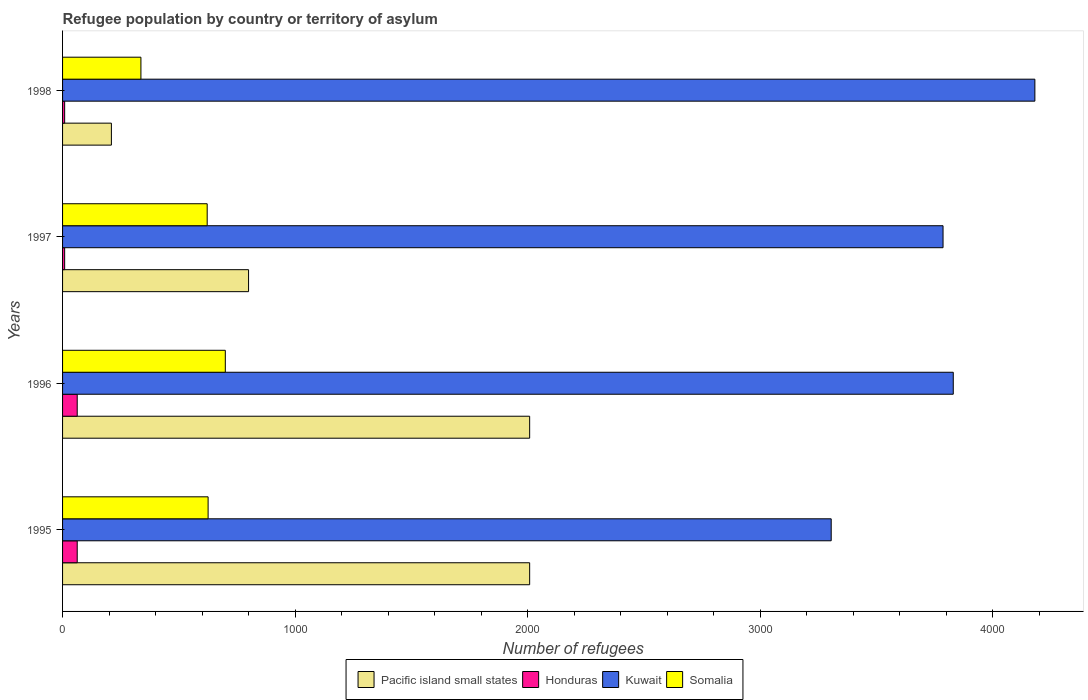How many different coloured bars are there?
Your answer should be compact. 4. How many groups of bars are there?
Your answer should be very brief. 4. What is the label of the 1st group of bars from the top?
Your answer should be very brief. 1998. In how many cases, is the number of bars for a given year not equal to the number of legend labels?
Ensure brevity in your answer.  0. What is the number of refugees in Somalia in 1995?
Offer a very short reply. 626. Across all years, what is the maximum number of refugees in Kuwait?
Keep it short and to the point. 4182. Across all years, what is the minimum number of refugees in Somalia?
Offer a very short reply. 337. In which year was the number of refugees in Pacific island small states maximum?
Keep it short and to the point. 1995. In which year was the number of refugees in Kuwait minimum?
Offer a terse response. 1995. What is the total number of refugees in Somalia in the graph?
Provide a short and direct response. 2285. What is the difference between the number of refugees in Honduras in 1996 and that in 1997?
Your response must be concise. 54. What is the difference between the number of refugees in Pacific island small states in 1996 and the number of refugees in Honduras in 1998?
Offer a very short reply. 2000. What is the average number of refugees in Kuwait per year?
Keep it short and to the point. 3776.5. In the year 1995, what is the difference between the number of refugees in Honduras and number of refugees in Pacific island small states?
Provide a short and direct response. -1946. In how many years, is the number of refugees in Kuwait greater than 600 ?
Provide a succinct answer. 4. What is the ratio of the number of refugees in Honduras in 1995 to that in 1998?
Keep it short and to the point. 7. Is the difference between the number of refugees in Honduras in 1996 and 1998 greater than the difference between the number of refugees in Pacific island small states in 1996 and 1998?
Keep it short and to the point. No. What is the difference between the highest and the lowest number of refugees in Pacific island small states?
Your response must be concise. 1799. Is the sum of the number of refugees in Kuwait in 1997 and 1998 greater than the maximum number of refugees in Honduras across all years?
Offer a very short reply. Yes. What does the 2nd bar from the top in 1997 represents?
Make the answer very short. Kuwait. What does the 2nd bar from the bottom in 1998 represents?
Your response must be concise. Honduras. How many bars are there?
Make the answer very short. 16. Are all the bars in the graph horizontal?
Your answer should be very brief. Yes. How many years are there in the graph?
Provide a succinct answer. 4. What is the difference between two consecutive major ticks on the X-axis?
Provide a succinct answer. 1000. Are the values on the major ticks of X-axis written in scientific E-notation?
Offer a very short reply. No. Does the graph contain any zero values?
Your answer should be very brief. No. Does the graph contain grids?
Ensure brevity in your answer.  No. Where does the legend appear in the graph?
Ensure brevity in your answer.  Bottom center. How many legend labels are there?
Offer a very short reply. 4. How are the legend labels stacked?
Provide a short and direct response. Horizontal. What is the title of the graph?
Give a very brief answer. Refugee population by country or territory of asylum. What is the label or title of the X-axis?
Offer a very short reply. Number of refugees. What is the Number of refugees in Pacific island small states in 1995?
Provide a succinct answer. 2009. What is the Number of refugees in Honduras in 1995?
Provide a succinct answer. 63. What is the Number of refugees of Kuwait in 1995?
Provide a succinct answer. 3306. What is the Number of refugees of Somalia in 1995?
Give a very brief answer. 626. What is the Number of refugees in Pacific island small states in 1996?
Your answer should be very brief. 2009. What is the Number of refugees of Honduras in 1996?
Make the answer very short. 63. What is the Number of refugees of Kuwait in 1996?
Your response must be concise. 3831. What is the Number of refugees of Somalia in 1996?
Ensure brevity in your answer.  700. What is the Number of refugees in Pacific island small states in 1997?
Make the answer very short. 800. What is the Number of refugees of Honduras in 1997?
Your answer should be compact. 9. What is the Number of refugees in Kuwait in 1997?
Make the answer very short. 3787. What is the Number of refugees of Somalia in 1997?
Your answer should be very brief. 622. What is the Number of refugees of Pacific island small states in 1998?
Offer a terse response. 210. What is the Number of refugees of Honduras in 1998?
Keep it short and to the point. 9. What is the Number of refugees of Kuwait in 1998?
Keep it short and to the point. 4182. What is the Number of refugees of Somalia in 1998?
Provide a succinct answer. 337. Across all years, what is the maximum Number of refugees of Pacific island small states?
Your answer should be compact. 2009. Across all years, what is the maximum Number of refugees in Honduras?
Your answer should be very brief. 63. Across all years, what is the maximum Number of refugees in Kuwait?
Give a very brief answer. 4182. Across all years, what is the maximum Number of refugees of Somalia?
Offer a very short reply. 700. Across all years, what is the minimum Number of refugees of Pacific island small states?
Offer a terse response. 210. Across all years, what is the minimum Number of refugees of Honduras?
Your answer should be compact. 9. Across all years, what is the minimum Number of refugees of Kuwait?
Provide a short and direct response. 3306. Across all years, what is the minimum Number of refugees of Somalia?
Ensure brevity in your answer.  337. What is the total Number of refugees in Pacific island small states in the graph?
Offer a very short reply. 5028. What is the total Number of refugees in Honduras in the graph?
Keep it short and to the point. 144. What is the total Number of refugees in Kuwait in the graph?
Your answer should be very brief. 1.51e+04. What is the total Number of refugees of Somalia in the graph?
Your response must be concise. 2285. What is the difference between the Number of refugees in Kuwait in 1995 and that in 1996?
Give a very brief answer. -525. What is the difference between the Number of refugees in Somalia in 1995 and that in 1996?
Provide a short and direct response. -74. What is the difference between the Number of refugees of Pacific island small states in 1995 and that in 1997?
Your answer should be very brief. 1209. What is the difference between the Number of refugees of Kuwait in 1995 and that in 1997?
Provide a short and direct response. -481. What is the difference between the Number of refugees of Somalia in 1995 and that in 1997?
Provide a succinct answer. 4. What is the difference between the Number of refugees in Pacific island small states in 1995 and that in 1998?
Provide a succinct answer. 1799. What is the difference between the Number of refugees in Kuwait in 1995 and that in 1998?
Make the answer very short. -876. What is the difference between the Number of refugees of Somalia in 1995 and that in 1998?
Your answer should be very brief. 289. What is the difference between the Number of refugees in Pacific island small states in 1996 and that in 1997?
Offer a terse response. 1209. What is the difference between the Number of refugees of Kuwait in 1996 and that in 1997?
Your answer should be compact. 44. What is the difference between the Number of refugees in Somalia in 1996 and that in 1997?
Give a very brief answer. 78. What is the difference between the Number of refugees in Pacific island small states in 1996 and that in 1998?
Provide a short and direct response. 1799. What is the difference between the Number of refugees in Kuwait in 1996 and that in 1998?
Make the answer very short. -351. What is the difference between the Number of refugees of Somalia in 1996 and that in 1998?
Keep it short and to the point. 363. What is the difference between the Number of refugees of Pacific island small states in 1997 and that in 1998?
Keep it short and to the point. 590. What is the difference between the Number of refugees of Kuwait in 1997 and that in 1998?
Give a very brief answer. -395. What is the difference between the Number of refugees of Somalia in 1997 and that in 1998?
Make the answer very short. 285. What is the difference between the Number of refugees in Pacific island small states in 1995 and the Number of refugees in Honduras in 1996?
Provide a short and direct response. 1946. What is the difference between the Number of refugees in Pacific island small states in 1995 and the Number of refugees in Kuwait in 1996?
Keep it short and to the point. -1822. What is the difference between the Number of refugees in Pacific island small states in 1995 and the Number of refugees in Somalia in 1996?
Your answer should be very brief. 1309. What is the difference between the Number of refugees in Honduras in 1995 and the Number of refugees in Kuwait in 1996?
Give a very brief answer. -3768. What is the difference between the Number of refugees of Honduras in 1995 and the Number of refugees of Somalia in 1996?
Your answer should be very brief. -637. What is the difference between the Number of refugees in Kuwait in 1995 and the Number of refugees in Somalia in 1996?
Your answer should be compact. 2606. What is the difference between the Number of refugees of Pacific island small states in 1995 and the Number of refugees of Kuwait in 1997?
Provide a succinct answer. -1778. What is the difference between the Number of refugees in Pacific island small states in 1995 and the Number of refugees in Somalia in 1997?
Your answer should be very brief. 1387. What is the difference between the Number of refugees of Honduras in 1995 and the Number of refugees of Kuwait in 1997?
Provide a short and direct response. -3724. What is the difference between the Number of refugees in Honduras in 1995 and the Number of refugees in Somalia in 1997?
Make the answer very short. -559. What is the difference between the Number of refugees of Kuwait in 1995 and the Number of refugees of Somalia in 1997?
Your response must be concise. 2684. What is the difference between the Number of refugees of Pacific island small states in 1995 and the Number of refugees of Honduras in 1998?
Keep it short and to the point. 2000. What is the difference between the Number of refugees of Pacific island small states in 1995 and the Number of refugees of Kuwait in 1998?
Your answer should be very brief. -2173. What is the difference between the Number of refugees of Pacific island small states in 1995 and the Number of refugees of Somalia in 1998?
Your response must be concise. 1672. What is the difference between the Number of refugees of Honduras in 1995 and the Number of refugees of Kuwait in 1998?
Provide a succinct answer. -4119. What is the difference between the Number of refugees of Honduras in 1995 and the Number of refugees of Somalia in 1998?
Offer a terse response. -274. What is the difference between the Number of refugees of Kuwait in 1995 and the Number of refugees of Somalia in 1998?
Your answer should be compact. 2969. What is the difference between the Number of refugees in Pacific island small states in 1996 and the Number of refugees in Kuwait in 1997?
Your response must be concise. -1778. What is the difference between the Number of refugees in Pacific island small states in 1996 and the Number of refugees in Somalia in 1997?
Make the answer very short. 1387. What is the difference between the Number of refugees in Honduras in 1996 and the Number of refugees in Kuwait in 1997?
Provide a short and direct response. -3724. What is the difference between the Number of refugees of Honduras in 1996 and the Number of refugees of Somalia in 1997?
Offer a very short reply. -559. What is the difference between the Number of refugees in Kuwait in 1996 and the Number of refugees in Somalia in 1997?
Provide a succinct answer. 3209. What is the difference between the Number of refugees of Pacific island small states in 1996 and the Number of refugees of Kuwait in 1998?
Make the answer very short. -2173. What is the difference between the Number of refugees of Pacific island small states in 1996 and the Number of refugees of Somalia in 1998?
Your answer should be compact. 1672. What is the difference between the Number of refugees in Honduras in 1996 and the Number of refugees in Kuwait in 1998?
Your answer should be very brief. -4119. What is the difference between the Number of refugees in Honduras in 1996 and the Number of refugees in Somalia in 1998?
Make the answer very short. -274. What is the difference between the Number of refugees of Kuwait in 1996 and the Number of refugees of Somalia in 1998?
Offer a very short reply. 3494. What is the difference between the Number of refugees of Pacific island small states in 1997 and the Number of refugees of Honduras in 1998?
Your answer should be compact. 791. What is the difference between the Number of refugees of Pacific island small states in 1997 and the Number of refugees of Kuwait in 1998?
Provide a succinct answer. -3382. What is the difference between the Number of refugees in Pacific island small states in 1997 and the Number of refugees in Somalia in 1998?
Offer a very short reply. 463. What is the difference between the Number of refugees in Honduras in 1997 and the Number of refugees in Kuwait in 1998?
Provide a short and direct response. -4173. What is the difference between the Number of refugees in Honduras in 1997 and the Number of refugees in Somalia in 1998?
Your answer should be compact. -328. What is the difference between the Number of refugees in Kuwait in 1997 and the Number of refugees in Somalia in 1998?
Your answer should be very brief. 3450. What is the average Number of refugees of Pacific island small states per year?
Your answer should be compact. 1257. What is the average Number of refugees in Honduras per year?
Offer a very short reply. 36. What is the average Number of refugees in Kuwait per year?
Your response must be concise. 3776.5. What is the average Number of refugees of Somalia per year?
Give a very brief answer. 571.25. In the year 1995, what is the difference between the Number of refugees in Pacific island small states and Number of refugees in Honduras?
Make the answer very short. 1946. In the year 1995, what is the difference between the Number of refugees of Pacific island small states and Number of refugees of Kuwait?
Offer a terse response. -1297. In the year 1995, what is the difference between the Number of refugees in Pacific island small states and Number of refugees in Somalia?
Your answer should be compact. 1383. In the year 1995, what is the difference between the Number of refugees of Honduras and Number of refugees of Kuwait?
Give a very brief answer. -3243. In the year 1995, what is the difference between the Number of refugees in Honduras and Number of refugees in Somalia?
Your answer should be very brief. -563. In the year 1995, what is the difference between the Number of refugees in Kuwait and Number of refugees in Somalia?
Ensure brevity in your answer.  2680. In the year 1996, what is the difference between the Number of refugees in Pacific island small states and Number of refugees in Honduras?
Keep it short and to the point. 1946. In the year 1996, what is the difference between the Number of refugees in Pacific island small states and Number of refugees in Kuwait?
Provide a short and direct response. -1822. In the year 1996, what is the difference between the Number of refugees of Pacific island small states and Number of refugees of Somalia?
Offer a terse response. 1309. In the year 1996, what is the difference between the Number of refugees in Honduras and Number of refugees in Kuwait?
Your answer should be very brief. -3768. In the year 1996, what is the difference between the Number of refugees in Honduras and Number of refugees in Somalia?
Provide a succinct answer. -637. In the year 1996, what is the difference between the Number of refugees of Kuwait and Number of refugees of Somalia?
Provide a short and direct response. 3131. In the year 1997, what is the difference between the Number of refugees in Pacific island small states and Number of refugees in Honduras?
Give a very brief answer. 791. In the year 1997, what is the difference between the Number of refugees of Pacific island small states and Number of refugees of Kuwait?
Ensure brevity in your answer.  -2987. In the year 1997, what is the difference between the Number of refugees in Pacific island small states and Number of refugees in Somalia?
Provide a succinct answer. 178. In the year 1997, what is the difference between the Number of refugees of Honduras and Number of refugees of Kuwait?
Ensure brevity in your answer.  -3778. In the year 1997, what is the difference between the Number of refugees of Honduras and Number of refugees of Somalia?
Make the answer very short. -613. In the year 1997, what is the difference between the Number of refugees of Kuwait and Number of refugees of Somalia?
Offer a very short reply. 3165. In the year 1998, what is the difference between the Number of refugees of Pacific island small states and Number of refugees of Honduras?
Provide a succinct answer. 201. In the year 1998, what is the difference between the Number of refugees of Pacific island small states and Number of refugees of Kuwait?
Keep it short and to the point. -3972. In the year 1998, what is the difference between the Number of refugees of Pacific island small states and Number of refugees of Somalia?
Your answer should be very brief. -127. In the year 1998, what is the difference between the Number of refugees of Honduras and Number of refugees of Kuwait?
Offer a terse response. -4173. In the year 1998, what is the difference between the Number of refugees in Honduras and Number of refugees in Somalia?
Offer a terse response. -328. In the year 1998, what is the difference between the Number of refugees in Kuwait and Number of refugees in Somalia?
Give a very brief answer. 3845. What is the ratio of the Number of refugees of Kuwait in 1995 to that in 1996?
Offer a terse response. 0.86. What is the ratio of the Number of refugees of Somalia in 1995 to that in 1996?
Your answer should be compact. 0.89. What is the ratio of the Number of refugees of Pacific island small states in 1995 to that in 1997?
Offer a terse response. 2.51. What is the ratio of the Number of refugees of Kuwait in 1995 to that in 1997?
Offer a very short reply. 0.87. What is the ratio of the Number of refugees of Somalia in 1995 to that in 1997?
Provide a short and direct response. 1.01. What is the ratio of the Number of refugees in Pacific island small states in 1995 to that in 1998?
Your answer should be very brief. 9.57. What is the ratio of the Number of refugees of Honduras in 1995 to that in 1998?
Provide a short and direct response. 7. What is the ratio of the Number of refugees in Kuwait in 1995 to that in 1998?
Offer a very short reply. 0.79. What is the ratio of the Number of refugees of Somalia in 1995 to that in 1998?
Your answer should be compact. 1.86. What is the ratio of the Number of refugees in Pacific island small states in 1996 to that in 1997?
Your response must be concise. 2.51. What is the ratio of the Number of refugees of Honduras in 1996 to that in 1997?
Your response must be concise. 7. What is the ratio of the Number of refugees in Kuwait in 1996 to that in 1997?
Keep it short and to the point. 1.01. What is the ratio of the Number of refugees of Somalia in 1996 to that in 1997?
Give a very brief answer. 1.13. What is the ratio of the Number of refugees of Pacific island small states in 1996 to that in 1998?
Offer a terse response. 9.57. What is the ratio of the Number of refugees in Honduras in 1996 to that in 1998?
Offer a terse response. 7. What is the ratio of the Number of refugees in Kuwait in 1996 to that in 1998?
Make the answer very short. 0.92. What is the ratio of the Number of refugees in Somalia in 1996 to that in 1998?
Keep it short and to the point. 2.08. What is the ratio of the Number of refugees in Pacific island small states in 1997 to that in 1998?
Your answer should be very brief. 3.81. What is the ratio of the Number of refugees in Kuwait in 1997 to that in 1998?
Ensure brevity in your answer.  0.91. What is the ratio of the Number of refugees in Somalia in 1997 to that in 1998?
Make the answer very short. 1.85. What is the difference between the highest and the second highest Number of refugees of Honduras?
Ensure brevity in your answer.  0. What is the difference between the highest and the second highest Number of refugees of Kuwait?
Your answer should be compact. 351. What is the difference between the highest and the lowest Number of refugees of Pacific island small states?
Offer a very short reply. 1799. What is the difference between the highest and the lowest Number of refugees in Kuwait?
Your answer should be compact. 876. What is the difference between the highest and the lowest Number of refugees in Somalia?
Make the answer very short. 363. 